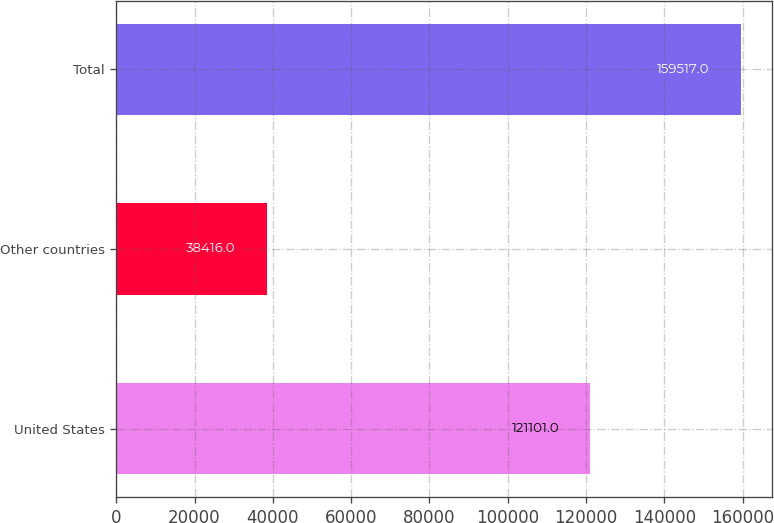Convert chart. <chart><loc_0><loc_0><loc_500><loc_500><bar_chart><fcel>United States<fcel>Other countries<fcel>Total<nl><fcel>121101<fcel>38416<fcel>159517<nl></chart> 